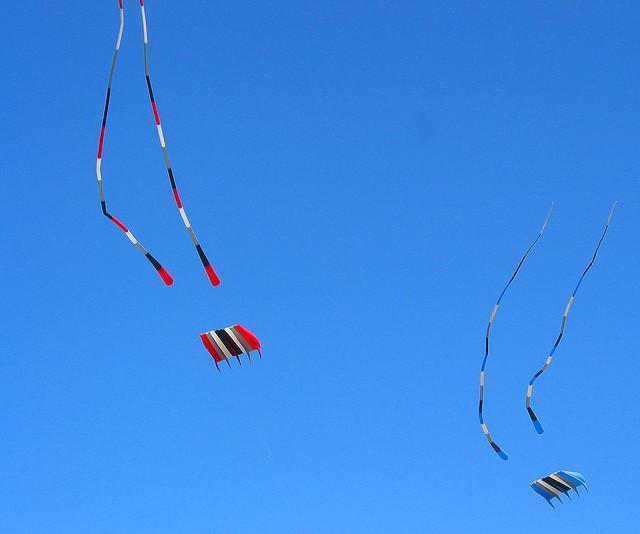How many horses are there?
Give a very brief answer. 0. 